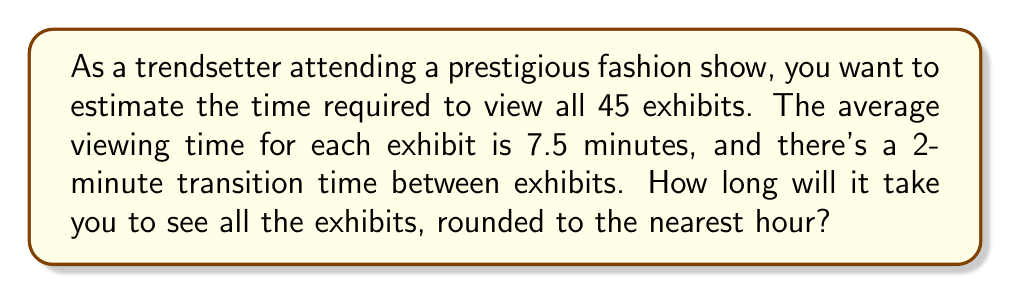Give your solution to this math problem. Let's break this problem down step-by-step:

1. Calculate the total viewing time for all exhibits:
   $$ \text{Total viewing time} = \text{Number of exhibits} \times \text{Average viewing time} $$
   $$ = 45 \times 7.5 \text{ minutes} = 337.5 \text{ minutes} $$

2. Calculate the total transition time:
   $$ \text{Total transition time} = (\text{Number of exhibits} - 1) \times \text{Transition time} $$
   $$ = 44 \times 2 \text{ minutes} = 88 \text{ minutes} $$
   
   Note: We subtract 1 from the number of exhibits because there's no transition after the last exhibit.

3. Sum up the total time:
   $$ \text{Total time} = \text{Total viewing time} + \text{Total transition time} $$
   $$ = 337.5 \text{ minutes} + 88 \text{ minutes} = 425.5 \text{ minutes} $$

4. Convert minutes to hours:
   $$ \text{Hours} = \frac{\text{Total minutes}}{60} = \frac{425.5}{60} \approx 7.09 \text{ hours} $$

5. Round to the nearest hour:
   7.09 hours rounds to 7 hours.
Answer: 7 hours 